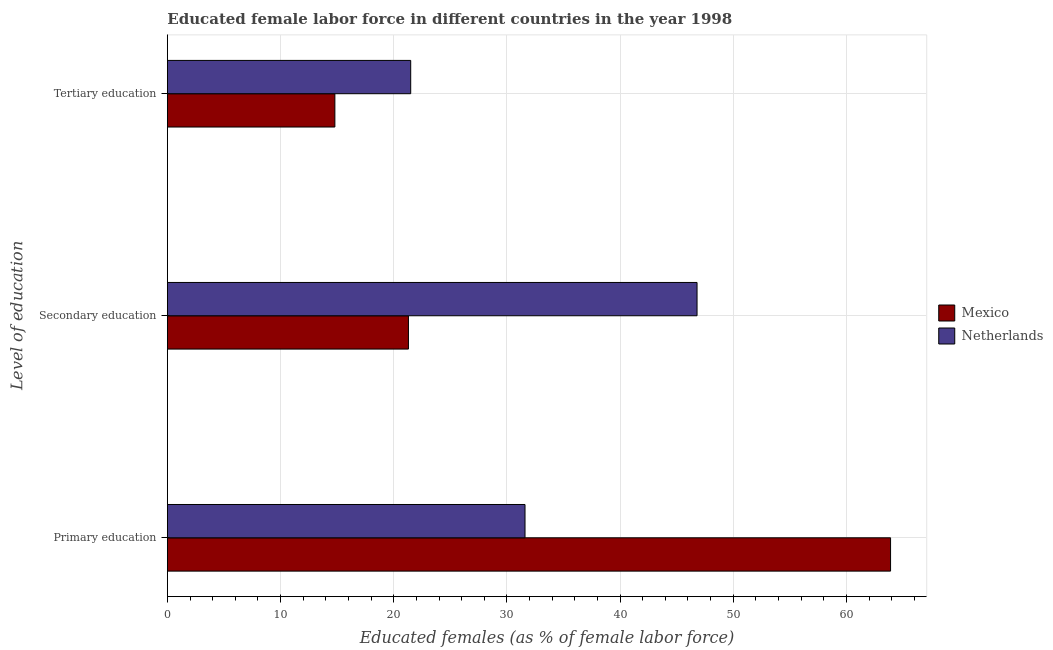How many different coloured bars are there?
Offer a terse response. 2. How many groups of bars are there?
Offer a terse response. 3. Are the number of bars per tick equal to the number of legend labels?
Provide a succinct answer. Yes. Are the number of bars on each tick of the Y-axis equal?
Make the answer very short. Yes. How many bars are there on the 2nd tick from the bottom?
Provide a short and direct response. 2. What is the label of the 2nd group of bars from the top?
Your answer should be compact. Secondary education. What is the percentage of female labor force who received secondary education in Mexico?
Your answer should be compact. 21.3. Across all countries, what is the maximum percentage of female labor force who received tertiary education?
Ensure brevity in your answer.  21.5. Across all countries, what is the minimum percentage of female labor force who received tertiary education?
Provide a short and direct response. 14.8. In which country was the percentage of female labor force who received secondary education maximum?
Your answer should be compact. Netherlands. In which country was the percentage of female labor force who received secondary education minimum?
Give a very brief answer. Mexico. What is the total percentage of female labor force who received tertiary education in the graph?
Provide a succinct answer. 36.3. What is the difference between the percentage of female labor force who received secondary education in Netherlands and that in Mexico?
Give a very brief answer. 25.5. What is the difference between the percentage of female labor force who received tertiary education in Mexico and the percentage of female labor force who received primary education in Netherlands?
Your response must be concise. -16.8. What is the average percentage of female labor force who received primary education per country?
Your response must be concise. 47.75. What is the difference between the percentage of female labor force who received tertiary education and percentage of female labor force who received secondary education in Netherlands?
Your response must be concise. -25.3. In how many countries, is the percentage of female labor force who received secondary education greater than 10 %?
Your answer should be compact. 2. What is the ratio of the percentage of female labor force who received primary education in Mexico to that in Netherlands?
Make the answer very short. 2.02. What is the difference between the highest and the second highest percentage of female labor force who received secondary education?
Provide a short and direct response. 25.5. What is the difference between the highest and the lowest percentage of female labor force who received secondary education?
Provide a short and direct response. 25.5. In how many countries, is the percentage of female labor force who received primary education greater than the average percentage of female labor force who received primary education taken over all countries?
Your answer should be very brief. 1. How many bars are there?
Give a very brief answer. 6. Are all the bars in the graph horizontal?
Offer a terse response. Yes. Does the graph contain any zero values?
Give a very brief answer. No. Where does the legend appear in the graph?
Keep it short and to the point. Center right. How many legend labels are there?
Provide a short and direct response. 2. What is the title of the graph?
Your answer should be compact. Educated female labor force in different countries in the year 1998. Does "Romania" appear as one of the legend labels in the graph?
Your answer should be very brief. No. What is the label or title of the X-axis?
Offer a very short reply. Educated females (as % of female labor force). What is the label or title of the Y-axis?
Ensure brevity in your answer.  Level of education. What is the Educated females (as % of female labor force) of Mexico in Primary education?
Your answer should be very brief. 63.9. What is the Educated females (as % of female labor force) of Netherlands in Primary education?
Your answer should be compact. 31.6. What is the Educated females (as % of female labor force) of Mexico in Secondary education?
Ensure brevity in your answer.  21.3. What is the Educated females (as % of female labor force) of Netherlands in Secondary education?
Make the answer very short. 46.8. What is the Educated females (as % of female labor force) of Mexico in Tertiary education?
Provide a short and direct response. 14.8. What is the Educated females (as % of female labor force) of Netherlands in Tertiary education?
Keep it short and to the point. 21.5. Across all Level of education, what is the maximum Educated females (as % of female labor force) in Mexico?
Offer a very short reply. 63.9. Across all Level of education, what is the maximum Educated females (as % of female labor force) of Netherlands?
Make the answer very short. 46.8. Across all Level of education, what is the minimum Educated females (as % of female labor force) of Mexico?
Provide a succinct answer. 14.8. Across all Level of education, what is the minimum Educated females (as % of female labor force) of Netherlands?
Keep it short and to the point. 21.5. What is the total Educated females (as % of female labor force) of Mexico in the graph?
Give a very brief answer. 100. What is the total Educated females (as % of female labor force) of Netherlands in the graph?
Offer a very short reply. 99.9. What is the difference between the Educated females (as % of female labor force) of Mexico in Primary education and that in Secondary education?
Give a very brief answer. 42.6. What is the difference between the Educated females (as % of female labor force) in Netherlands in Primary education and that in Secondary education?
Keep it short and to the point. -15.2. What is the difference between the Educated females (as % of female labor force) in Mexico in Primary education and that in Tertiary education?
Make the answer very short. 49.1. What is the difference between the Educated females (as % of female labor force) of Netherlands in Secondary education and that in Tertiary education?
Ensure brevity in your answer.  25.3. What is the difference between the Educated females (as % of female labor force) in Mexico in Primary education and the Educated females (as % of female labor force) in Netherlands in Tertiary education?
Offer a terse response. 42.4. What is the difference between the Educated females (as % of female labor force) of Mexico in Secondary education and the Educated females (as % of female labor force) of Netherlands in Tertiary education?
Make the answer very short. -0.2. What is the average Educated females (as % of female labor force) in Mexico per Level of education?
Ensure brevity in your answer.  33.33. What is the average Educated females (as % of female labor force) in Netherlands per Level of education?
Keep it short and to the point. 33.3. What is the difference between the Educated females (as % of female labor force) in Mexico and Educated females (as % of female labor force) in Netherlands in Primary education?
Make the answer very short. 32.3. What is the difference between the Educated females (as % of female labor force) of Mexico and Educated females (as % of female labor force) of Netherlands in Secondary education?
Offer a very short reply. -25.5. What is the ratio of the Educated females (as % of female labor force) of Netherlands in Primary education to that in Secondary education?
Ensure brevity in your answer.  0.68. What is the ratio of the Educated females (as % of female labor force) of Mexico in Primary education to that in Tertiary education?
Your answer should be very brief. 4.32. What is the ratio of the Educated females (as % of female labor force) in Netherlands in Primary education to that in Tertiary education?
Your response must be concise. 1.47. What is the ratio of the Educated females (as % of female labor force) of Mexico in Secondary education to that in Tertiary education?
Ensure brevity in your answer.  1.44. What is the ratio of the Educated females (as % of female labor force) of Netherlands in Secondary education to that in Tertiary education?
Make the answer very short. 2.18. What is the difference between the highest and the second highest Educated females (as % of female labor force) of Mexico?
Offer a terse response. 42.6. What is the difference between the highest and the lowest Educated females (as % of female labor force) in Mexico?
Offer a very short reply. 49.1. What is the difference between the highest and the lowest Educated females (as % of female labor force) of Netherlands?
Your answer should be compact. 25.3. 